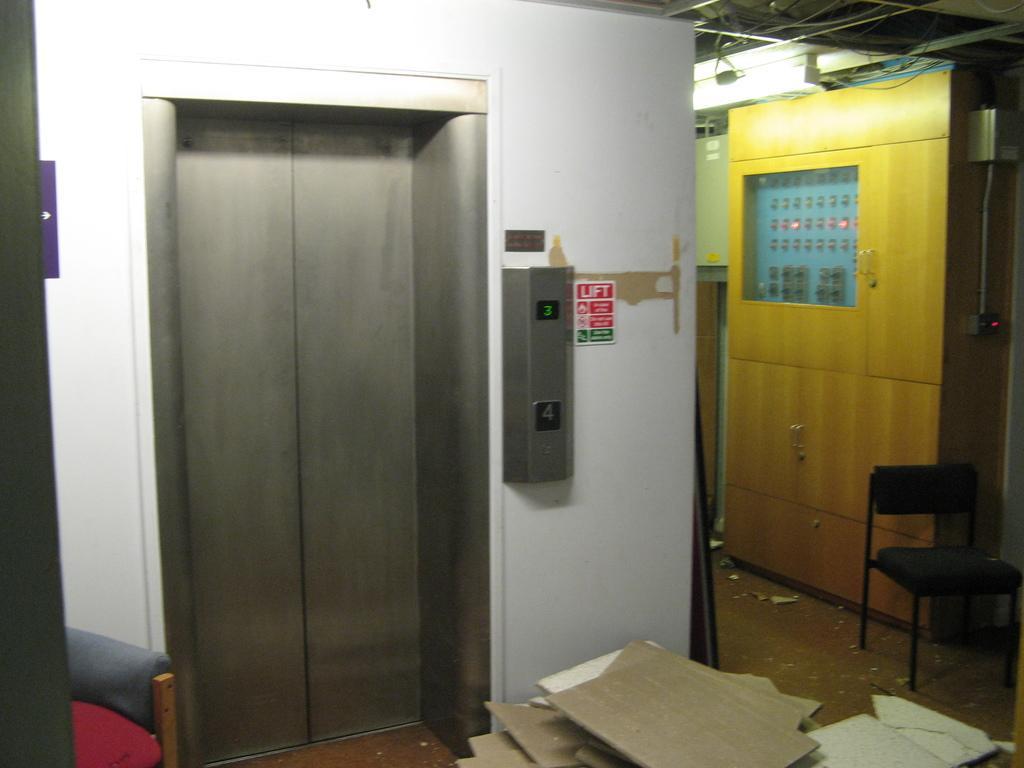Describe this image in one or two sentences. In this picture we can see many cardboard pieces on the floor in front of a lift door. On the right side, we can see a chair and a row with many buttons. 